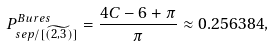<formula> <loc_0><loc_0><loc_500><loc_500>P ^ { B u r e s } _ { s e p / [ \widetilde { ( 2 , 3 ) } ] } = \frac { 4 C - 6 + \pi } { \pi } \approx 0 . 2 5 6 3 8 4 ,</formula> 